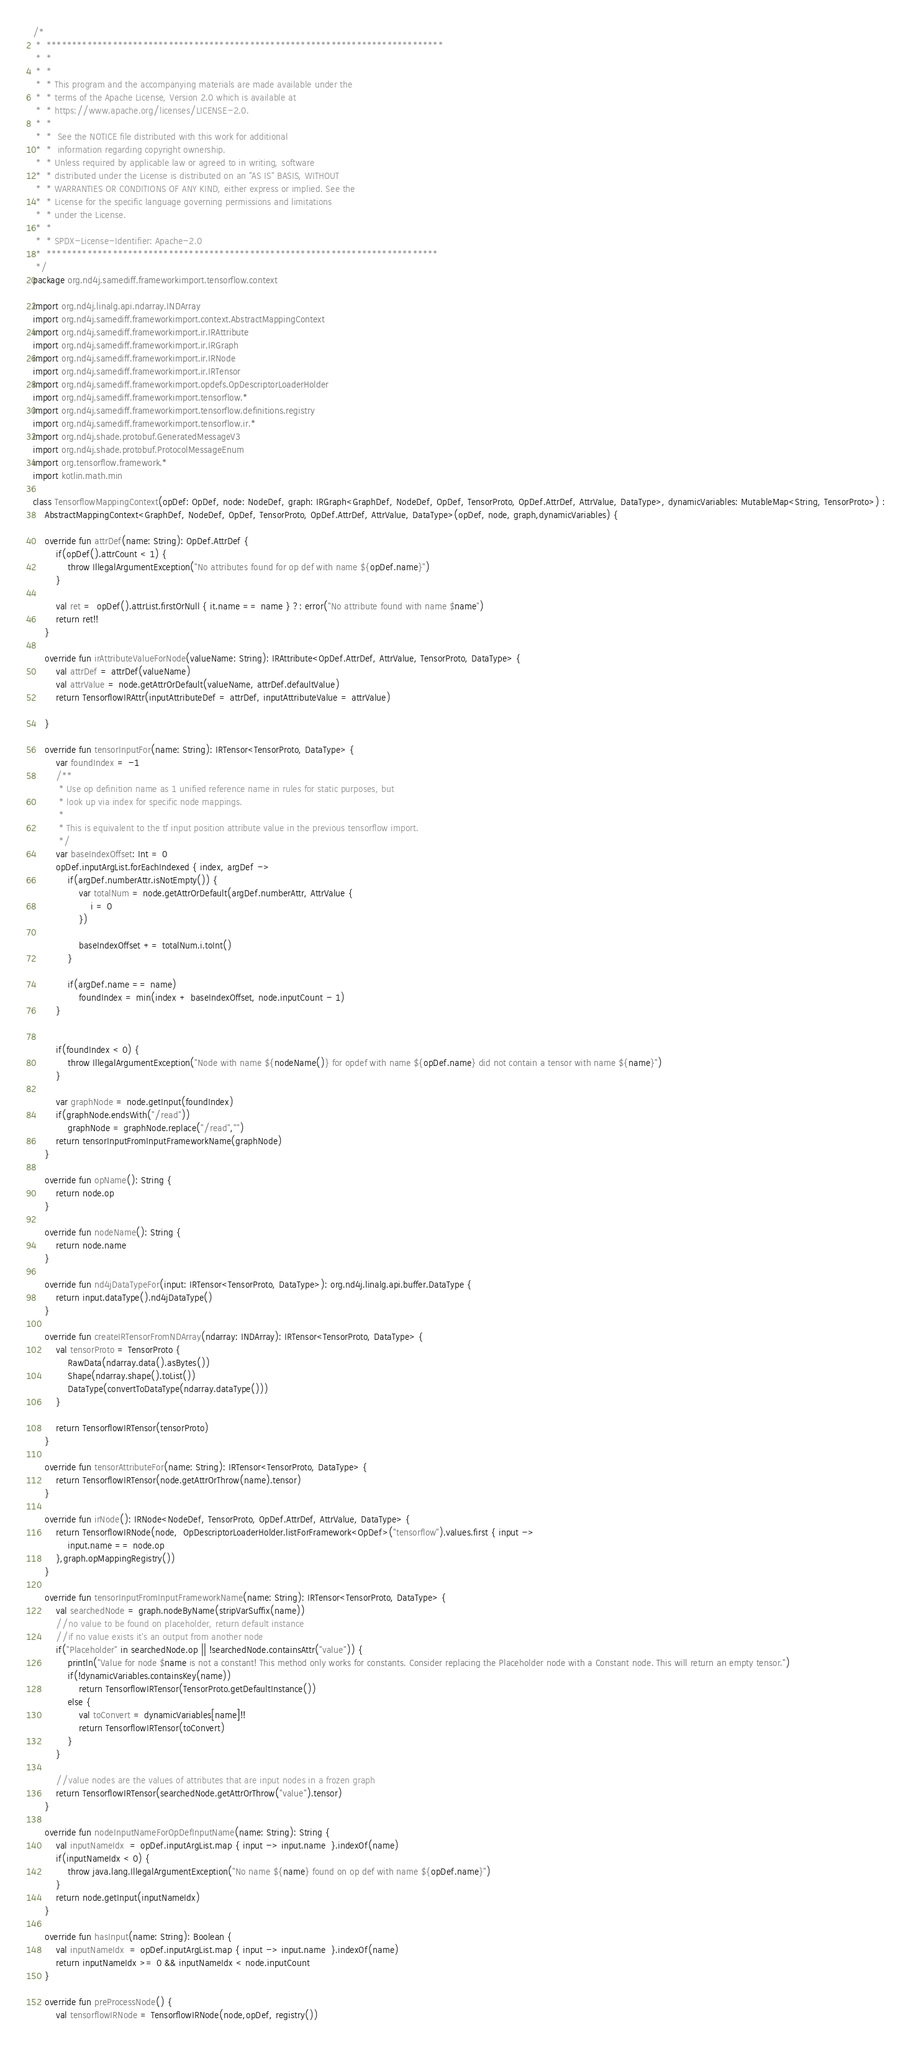<code> <loc_0><loc_0><loc_500><loc_500><_Kotlin_>/*
 *  ******************************************************************************
 *  *
 *  *
 *  * This program and the accompanying materials are made available under the
 *  * terms of the Apache License, Version 2.0 which is available at
 *  * https://www.apache.org/licenses/LICENSE-2.0.
 *  *
 *  *  See the NOTICE file distributed with this work for additional
 *  *  information regarding copyright ownership.
 *  * Unless required by applicable law or agreed to in writing, software
 *  * distributed under the License is distributed on an "AS IS" BASIS, WITHOUT
 *  * WARRANTIES OR CONDITIONS OF ANY KIND, either express or implied. See the
 *  * License for the specific language governing permissions and limitations
 *  * under the License.
 *  *
 *  * SPDX-License-Identifier: Apache-2.0
 *  *****************************************************************************
 */
package org.nd4j.samediff.frameworkimport.tensorflow.context

import org.nd4j.linalg.api.ndarray.INDArray
import org.nd4j.samediff.frameworkimport.context.AbstractMappingContext
import org.nd4j.samediff.frameworkimport.ir.IRAttribute
import org.nd4j.samediff.frameworkimport.ir.IRGraph
import org.nd4j.samediff.frameworkimport.ir.IRNode
import org.nd4j.samediff.frameworkimport.ir.IRTensor
import org.nd4j.samediff.frameworkimport.opdefs.OpDescriptorLoaderHolder
import org.nd4j.samediff.frameworkimport.tensorflow.*
import org.nd4j.samediff.frameworkimport.tensorflow.definitions.registry
import org.nd4j.samediff.frameworkimport.tensorflow.ir.*
import org.nd4j.shade.protobuf.GeneratedMessageV3
import org.nd4j.shade.protobuf.ProtocolMessageEnum
import org.tensorflow.framework.*
import kotlin.math.min

class TensorflowMappingContext(opDef: OpDef, node: NodeDef, graph: IRGraph<GraphDef, NodeDef, OpDef, TensorProto, OpDef.AttrDef, AttrValue, DataType>, dynamicVariables: MutableMap<String, TensorProto>) :
    AbstractMappingContext<GraphDef, NodeDef, OpDef, TensorProto, OpDef.AttrDef, AttrValue, DataType>(opDef, node, graph,dynamicVariables) {

    override fun attrDef(name: String): OpDef.AttrDef {
        if(opDef().attrCount < 1) {
            throw IllegalArgumentException("No attributes found for op def with name ${opDef.name}")
        }

        val ret =  opDef().attrList.firstOrNull { it.name == name } ?: error("No attribute found with name $name")
        return ret!!
    }

    override fun irAttributeValueForNode(valueName: String): IRAttribute<OpDef.AttrDef, AttrValue, TensorProto, DataType> {
        val attrDef = attrDef(valueName)
        val attrValue = node.getAttrOrDefault(valueName, attrDef.defaultValue)
        return TensorflowIRAttr(inputAttributeDef = attrDef, inputAttributeValue = attrValue)

    }

    override fun tensorInputFor(name: String): IRTensor<TensorProto, DataType> {
        var foundIndex = -1
        /**
         * Use op definition name as 1 unified reference name in rules for static purposes, but
         * look up via index for specific node mappings.
         *
         * This is equivalent to the tf input position attribute value in the previous tensorflow import.
         */
        var baseIndexOffset: Int = 0
        opDef.inputArgList.forEachIndexed { index, argDef ->
            if(argDef.numberAttr.isNotEmpty()) {
                var totalNum = node.getAttrOrDefault(argDef.numberAttr, AttrValue {
                    i = 0
                })

                baseIndexOffset += totalNum.i.toInt()
            }

            if(argDef.name == name)
                foundIndex = min(index + baseIndexOffset, node.inputCount - 1)
        }


        if(foundIndex < 0) {
            throw IllegalArgumentException("Node with name ${nodeName()} for opdef with name ${opDef.name} did not contain a tensor with name ${name}")
        }

        var graphNode = node.getInput(foundIndex)
        if(graphNode.endsWith("/read"))
            graphNode = graphNode.replace("/read","")
        return tensorInputFromInputFrameworkName(graphNode)
    }

    override fun opName(): String {
        return node.op
    }

    override fun nodeName(): String {
        return node.name
    }

    override fun nd4jDataTypeFor(input: IRTensor<TensorProto, DataType>): org.nd4j.linalg.api.buffer.DataType {
        return input.dataType().nd4jDataType()
    }

    override fun createIRTensorFromNDArray(ndarray: INDArray): IRTensor<TensorProto, DataType> {
        val tensorProto = TensorProto {
            RawData(ndarray.data().asBytes())
            Shape(ndarray.shape().toList())
            DataType(convertToDataType(ndarray.dataType()))
        }

        return TensorflowIRTensor(tensorProto)
    }

    override fun tensorAttributeFor(name: String): IRTensor<TensorProto, DataType> {
        return TensorflowIRTensor(node.getAttrOrThrow(name).tensor)
    }

    override fun irNode(): IRNode<NodeDef, TensorProto, OpDef.AttrDef, AttrValue, DataType> {
        return TensorflowIRNode(node,  OpDescriptorLoaderHolder.listForFramework<OpDef>("tensorflow").values.first { input ->
            input.name == node.op
        },graph.opMappingRegistry())
    }

    override fun tensorInputFromInputFrameworkName(name: String): IRTensor<TensorProto, DataType> {
        val searchedNode = graph.nodeByName(stripVarSuffix(name))
        //no value to be found on placeholder, return default instance
        //if no value exists it's an output from another node
        if("Placeholder" in searchedNode.op || !searchedNode.containsAttr("value")) {
            println("Value for node $name is not a constant! This method only works for constants. Consider replacing the Placeholder node with a Constant node. This will return an empty tensor.")
            if(!dynamicVariables.containsKey(name))
                return TensorflowIRTensor(TensorProto.getDefaultInstance())
            else {
                val toConvert = dynamicVariables[name]!!
                return TensorflowIRTensor(toConvert)
            }
        }

        //value nodes are the values of attributes that are input nodes in a frozen graph
        return TensorflowIRTensor(searchedNode.getAttrOrThrow("value").tensor)
    }

    override fun nodeInputNameForOpDefInputName(name: String): String {
        val inputNameIdx  = opDef.inputArgList.map { input -> input.name  }.indexOf(name)
        if(inputNameIdx < 0) {
            throw java.lang.IllegalArgumentException("No name ${name} found on op def with name ${opDef.name}")
        }
        return node.getInput(inputNameIdx)
    }

    override fun hasInput(name: String): Boolean {
        val inputNameIdx  = opDef.inputArgList.map { input -> input.name  }.indexOf(name)
        return inputNameIdx >= 0 && inputNameIdx < node.inputCount
    }

    override fun preProcessNode() {
        val tensorflowIRNode = TensorflowIRNode(node,opDef, registry())</code> 